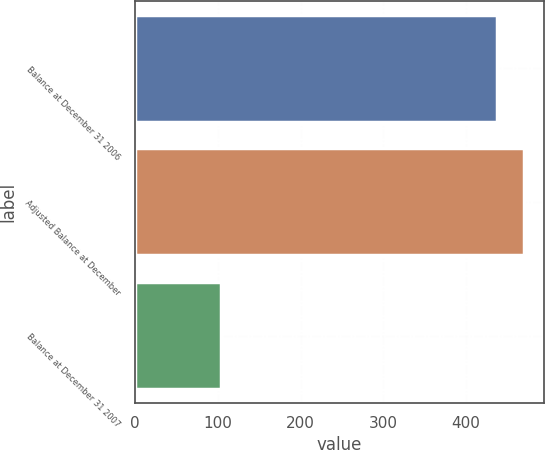Convert chart to OTSL. <chart><loc_0><loc_0><loc_500><loc_500><bar_chart><fcel>Balance at December 31 2006<fcel>Adjusted Balance at December<fcel>Balance at December 31 2007<nl><fcel>437<fcel>470.3<fcel>104<nl></chart> 